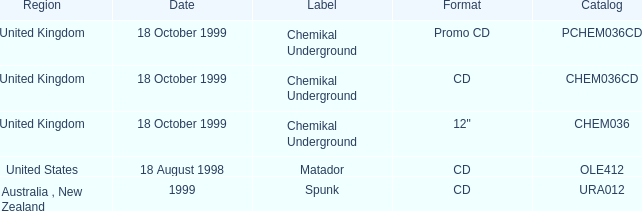What designation features a directory of chem036cd? Chemikal Underground. 